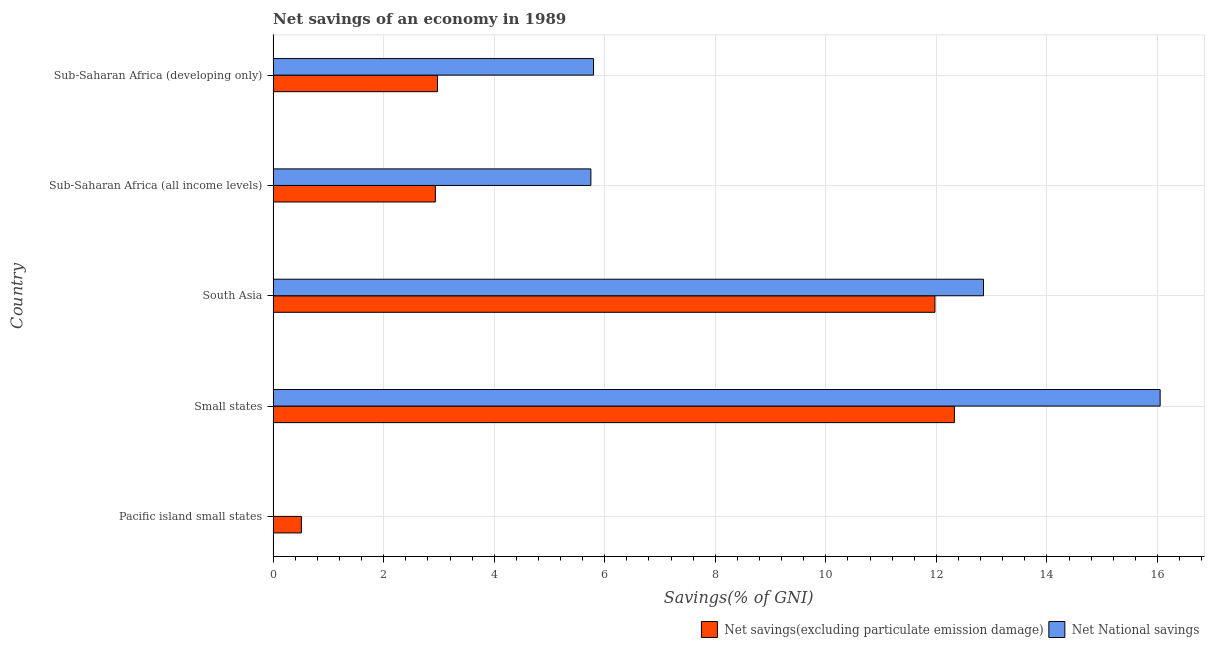How many different coloured bars are there?
Your response must be concise. 2. Are the number of bars per tick equal to the number of legend labels?
Provide a succinct answer. No. How many bars are there on the 1st tick from the bottom?
Ensure brevity in your answer.  1. What is the label of the 2nd group of bars from the top?
Keep it short and to the point. Sub-Saharan Africa (all income levels). What is the net savings(excluding particulate emission damage) in Small states?
Offer a terse response. 12.33. Across all countries, what is the maximum net savings(excluding particulate emission damage)?
Offer a terse response. 12.33. Across all countries, what is the minimum net national savings?
Provide a succinct answer. 0. In which country was the net savings(excluding particulate emission damage) maximum?
Provide a short and direct response. Small states. What is the total net savings(excluding particulate emission damage) in the graph?
Provide a succinct answer. 30.72. What is the difference between the net national savings in Small states and that in Sub-Saharan Africa (developing only)?
Offer a very short reply. 10.25. What is the difference between the net national savings in Sub-Saharan Africa (all income levels) and the net savings(excluding particulate emission damage) in Small states?
Provide a short and direct response. -6.58. What is the average net savings(excluding particulate emission damage) per country?
Your answer should be compact. 6.14. What is the difference between the net national savings and net savings(excluding particulate emission damage) in Sub-Saharan Africa (developing only)?
Give a very brief answer. 2.82. In how many countries, is the net savings(excluding particulate emission damage) greater than 13.6 %?
Offer a very short reply. 0. What is the ratio of the net savings(excluding particulate emission damage) in Small states to that in Sub-Saharan Africa (all income levels)?
Offer a very short reply. 4.2. Is the net national savings in South Asia less than that in Sub-Saharan Africa (developing only)?
Give a very brief answer. No. What is the difference between the highest and the second highest net savings(excluding particulate emission damage)?
Your answer should be very brief. 0.35. What is the difference between the highest and the lowest net savings(excluding particulate emission damage)?
Your answer should be compact. 11.81. How many bars are there?
Provide a short and direct response. 9. How many countries are there in the graph?
Offer a very short reply. 5. What is the difference between two consecutive major ticks on the X-axis?
Your answer should be very brief. 2. Does the graph contain grids?
Your response must be concise. Yes. Where does the legend appear in the graph?
Provide a short and direct response. Bottom right. How are the legend labels stacked?
Give a very brief answer. Horizontal. What is the title of the graph?
Your response must be concise. Net savings of an economy in 1989. Does "Infant" appear as one of the legend labels in the graph?
Provide a short and direct response. No. What is the label or title of the X-axis?
Offer a terse response. Savings(% of GNI). What is the label or title of the Y-axis?
Provide a succinct answer. Country. What is the Savings(% of GNI) in Net savings(excluding particulate emission damage) in Pacific island small states?
Make the answer very short. 0.51. What is the Savings(% of GNI) of Net National savings in Pacific island small states?
Provide a short and direct response. 0. What is the Savings(% of GNI) of Net savings(excluding particulate emission damage) in Small states?
Your answer should be very brief. 12.33. What is the Savings(% of GNI) of Net National savings in Small states?
Keep it short and to the point. 16.05. What is the Savings(% of GNI) in Net savings(excluding particulate emission damage) in South Asia?
Provide a short and direct response. 11.97. What is the Savings(% of GNI) of Net National savings in South Asia?
Your answer should be very brief. 12.85. What is the Savings(% of GNI) of Net savings(excluding particulate emission damage) in Sub-Saharan Africa (all income levels)?
Give a very brief answer. 2.94. What is the Savings(% of GNI) in Net National savings in Sub-Saharan Africa (all income levels)?
Provide a short and direct response. 5.75. What is the Savings(% of GNI) of Net savings(excluding particulate emission damage) in Sub-Saharan Africa (developing only)?
Give a very brief answer. 2.97. What is the Savings(% of GNI) in Net National savings in Sub-Saharan Africa (developing only)?
Give a very brief answer. 5.8. Across all countries, what is the maximum Savings(% of GNI) of Net savings(excluding particulate emission damage)?
Provide a succinct answer. 12.33. Across all countries, what is the maximum Savings(% of GNI) in Net National savings?
Provide a succinct answer. 16.05. Across all countries, what is the minimum Savings(% of GNI) of Net savings(excluding particulate emission damage)?
Ensure brevity in your answer.  0.51. What is the total Savings(% of GNI) of Net savings(excluding particulate emission damage) in the graph?
Offer a very short reply. 30.72. What is the total Savings(% of GNI) of Net National savings in the graph?
Your answer should be compact. 40.45. What is the difference between the Savings(% of GNI) of Net savings(excluding particulate emission damage) in Pacific island small states and that in Small states?
Your response must be concise. -11.81. What is the difference between the Savings(% of GNI) in Net savings(excluding particulate emission damage) in Pacific island small states and that in South Asia?
Your answer should be very brief. -11.46. What is the difference between the Savings(% of GNI) in Net savings(excluding particulate emission damage) in Pacific island small states and that in Sub-Saharan Africa (all income levels)?
Make the answer very short. -2.42. What is the difference between the Savings(% of GNI) in Net savings(excluding particulate emission damage) in Pacific island small states and that in Sub-Saharan Africa (developing only)?
Ensure brevity in your answer.  -2.46. What is the difference between the Savings(% of GNI) in Net savings(excluding particulate emission damage) in Small states and that in South Asia?
Keep it short and to the point. 0.35. What is the difference between the Savings(% of GNI) in Net National savings in Small states and that in South Asia?
Keep it short and to the point. 3.2. What is the difference between the Savings(% of GNI) in Net savings(excluding particulate emission damage) in Small states and that in Sub-Saharan Africa (all income levels)?
Keep it short and to the point. 9.39. What is the difference between the Savings(% of GNI) in Net National savings in Small states and that in Sub-Saharan Africa (all income levels)?
Offer a very short reply. 10.3. What is the difference between the Savings(% of GNI) of Net savings(excluding particulate emission damage) in Small states and that in Sub-Saharan Africa (developing only)?
Give a very brief answer. 9.35. What is the difference between the Savings(% of GNI) of Net National savings in Small states and that in Sub-Saharan Africa (developing only)?
Ensure brevity in your answer.  10.25. What is the difference between the Savings(% of GNI) of Net savings(excluding particulate emission damage) in South Asia and that in Sub-Saharan Africa (all income levels)?
Make the answer very short. 9.04. What is the difference between the Savings(% of GNI) in Net National savings in South Asia and that in Sub-Saharan Africa (all income levels)?
Your response must be concise. 7.1. What is the difference between the Savings(% of GNI) of Net savings(excluding particulate emission damage) in South Asia and that in Sub-Saharan Africa (developing only)?
Your answer should be very brief. 9. What is the difference between the Savings(% of GNI) of Net National savings in South Asia and that in Sub-Saharan Africa (developing only)?
Your answer should be compact. 7.05. What is the difference between the Savings(% of GNI) of Net savings(excluding particulate emission damage) in Sub-Saharan Africa (all income levels) and that in Sub-Saharan Africa (developing only)?
Make the answer very short. -0.04. What is the difference between the Savings(% of GNI) in Net National savings in Sub-Saharan Africa (all income levels) and that in Sub-Saharan Africa (developing only)?
Keep it short and to the point. -0.05. What is the difference between the Savings(% of GNI) of Net savings(excluding particulate emission damage) in Pacific island small states and the Savings(% of GNI) of Net National savings in Small states?
Keep it short and to the point. -15.54. What is the difference between the Savings(% of GNI) in Net savings(excluding particulate emission damage) in Pacific island small states and the Savings(% of GNI) in Net National savings in South Asia?
Give a very brief answer. -12.34. What is the difference between the Savings(% of GNI) in Net savings(excluding particulate emission damage) in Pacific island small states and the Savings(% of GNI) in Net National savings in Sub-Saharan Africa (all income levels)?
Your answer should be very brief. -5.24. What is the difference between the Savings(% of GNI) of Net savings(excluding particulate emission damage) in Pacific island small states and the Savings(% of GNI) of Net National savings in Sub-Saharan Africa (developing only)?
Keep it short and to the point. -5.29. What is the difference between the Savings(% of GNI) of Net savings(excluding particulate emission damage) in Small states and the Savings(% of GNI) of Net National savings in South Asia?
Offer a terse response. -0.53. What is the difference between the Savings(% of GNI) in Net savings(excluding particulate emission damage) in Small states and the Savings(% of GNI) in Net National savings in Sub-Saharan Africa (all income levels)?
Your answer should be compact. 6.58. What is the difference between the Savings(% of GNI) in Net savings(excluding particulate emission damage) in Small states and the Savings(% of GNI) in Net National savings in Sub-Saharan Africa (developing only)?
Your response must be concise. 6.53. What is the difference between the Savings(% of GNI) of Net savings(excluding particulate emission damage) in South Asia and the Savings(% of GNI) of Net National savings in Sub-Saharan Africa (all income levels)?
Give a very brief answer. 6.22. What is the difference between the Savings(% of GNI) in Net savings(excluding particulate emission damage) in South Asia and the Savings(% of GNI) in Net National savings in Sub-Saharan Africa (developing only)?
Offer a very short reply. 6.18. What is the difference between the Savings(% of GNI) of Net savings(excluding particulate emission damage) in Sub-Saharan Africa (all income levels) and the Savings(% of GNI) of Net National savings in Sub-Saharan Africa (developing only)?
Keep it short and to the point. -2.86. What is the average Savings(% of GNI) of Net savings(excluding particulate emission damage) per country?
Offer a terse response. 6.14. What is the average Savings(% of GNI) of Net National savings per country?
Give a very brief answer. 8.09. What is the difference between the Savings(% of GNI) of Net savings(excluding particulate emission damage) and Savings(% of GNI) of Net National savings in Small states?
Offer a very short reply. -3.72. What is the difference between the Savings(% of GNI) of Net savings(excluding particulate emission damage) and Savings(% of GNI) of Net National savings in South Asia?
Your response must be concise. -0.88. What is the difference between the Savings(% of GNI) in Net savings(excluding particulate emission damage) and Savings(% of GNI) in Net National savings in Sub-Saharan Africa (all income levels)?
Your answer should be very brief. -2.81. What is the difference between the Savings(% of GNI) in Net savings(excluding particulate emission damage) and Savings(% of GNI) in Net National savings in Sub-Saharan Africa (developing only)?
Provide a short and direct response. -2.82. What is the ratio of the Savings(% of GNI) of Net savings(excluding particulate emission damage) in Pacific island small states to that in Small states?
Provide a succinct answer. 0.04. What is the ratio of the Savings(% of GNI) in Net savings(excluding particulate emission damage) in Pacific island small states to that in South Asia?
Give a very brief answer. 0.04. What is the ratio of the Savings(% of GNI) in Net savings(excluding particulate emission damage) in Pacific island small states to that in Sub-Saharan Africa (all income levels)?
Provide a succinct answer. 0.17. What is the ratio of the Savings(% of GNI) in Net savings(excluding particulate emission damage) in Pacific island small states to that in Sub-Saharan Africa (developing only)?
Provide a short and direct response. 0.17. What is the ratio of the Savings(% of GNI) of Net savings(excluding particulate emission damage) in Small states to that in South Asia?
Offer a very short reply. 1.03. What is the ratio of the Savings(% of GNI) of Net National savings in Small states to that in South Asia?
Ensure brevity in your answer.  1.25. What is the ratio of the Savings(% of GNI) in Net savings(excluding particulate emission damage) in Small states to that in Sub-Saharan Africa (all income levels)?
Make the answer very short. 4.2. What is the ratio of the Savings(% of GNI) of Net National savings in Small states to that in Sub-Saharan Africa (all income levels)?
Offer a very short reply. 2.79. What is the ratio of the Savings(% of GNI) in Net savings(excluding particulate emission damage) in Small states to that in Sub-Saharan Africa (developing only)?
Keep it short and to the point. 4.15. What is the ratio of the Savings(% of GNI) of Net National savings in Small states to that in Sub-Saharan Africa (developing only)?
Make the answer very short. 2.77. What is the ratio of the Savings(% of GNI) of Net savings(excluding particulate emission damage) in South Asia to that in Sub-Saharan Africa (all income levels)?
Provide a short and direct response. 4.08. What is the ratio of the Savings(% of GNI) in Net National savings in South Asia to that in Sub-Saharan Africa (all income levels)?
Offer a very short reply. 2.24. What is the ratio of the Savings(% of GNI) of Net savings(excluding particulate emission damage) in South Asia to that in Sub-Saharan Africa (developing only)?
Provide a short and direct response. 4.03. What is the ratio of the Savings(% of GNI) of Net National savings in South Asia to that in Sub-Saharan Africa (developing only)?
Provide a short and direct response. 2.22. What is the ratio of the Savings(% of GNI) of Net savings(excluding particulate emission damage) in Sub-Saharan Africa (all income levels) to that in Sub-Saharan Africa (developing only)?
Keep it short and to the point. 0.99. What is the ratio of the Savings(% of GNI) in Net National savings in Sub-Saharan Africa (all income levels) to that in Sub-Saharan Africa (developing only)?
Offer a terse response. 0.99. What is the difference between the highest and the second highest Savings(% of GNI) in Net savings(excluding particulate emission damage)?
Provide a short and direct response. 0.35. What is the difference between the highest and the second highest Savings(% of GNI) of Net National savings?
Your answer should be compact. 3.2. What is the difference between the highest and the lowest Savings(% of GNI) of Net savings(excluding particulate emission damage)?
Offer a terse response. 11.81. What is the difference between the highest and the lowest Savings(% of GNI) of Net National savings?
Offer a terse response. 16.05. 